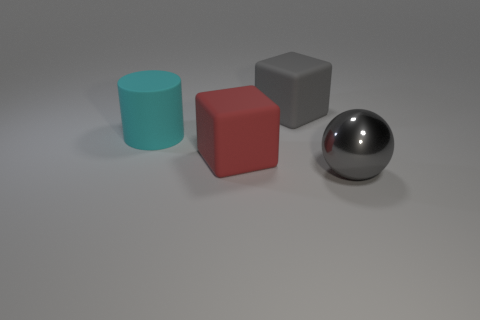Is there any other thing that is made of the same material as the large sphere?
Offer a very short reply. No. Do the metal sphere and the big rubber cube behind the cylinder have the same color?
Make the answer very short. Yes. What is the material of the thing that is right of the big red cube and in front of the cyan object?
Give a very brief answer. Metal. Is there another gray metallic ball of the same size as the ball?
Your response must be concise. No. There is a gray ball that is the same size as the cyan cylinder; what is it made of?
Ensure brevity in your answer.  Metal. How many large gray objects are behind the big cyan object?
Ensure brevity in your answer.  1. There is a gray thing that is to the left of the big gray ball; is its shape the same as the gray shiny thing?
Your answer should be compact. No. Is there another big thing of the same shape as the big red rubber object?
Offer a very short reply. Yes. What is the material of the big object that is the same color as the ball?
Provide a succinct answer. Rubber. The big thing to the left of the big matte block in front of the gray matte block is what shape?
Keep it short and to the point. Cylinder. 